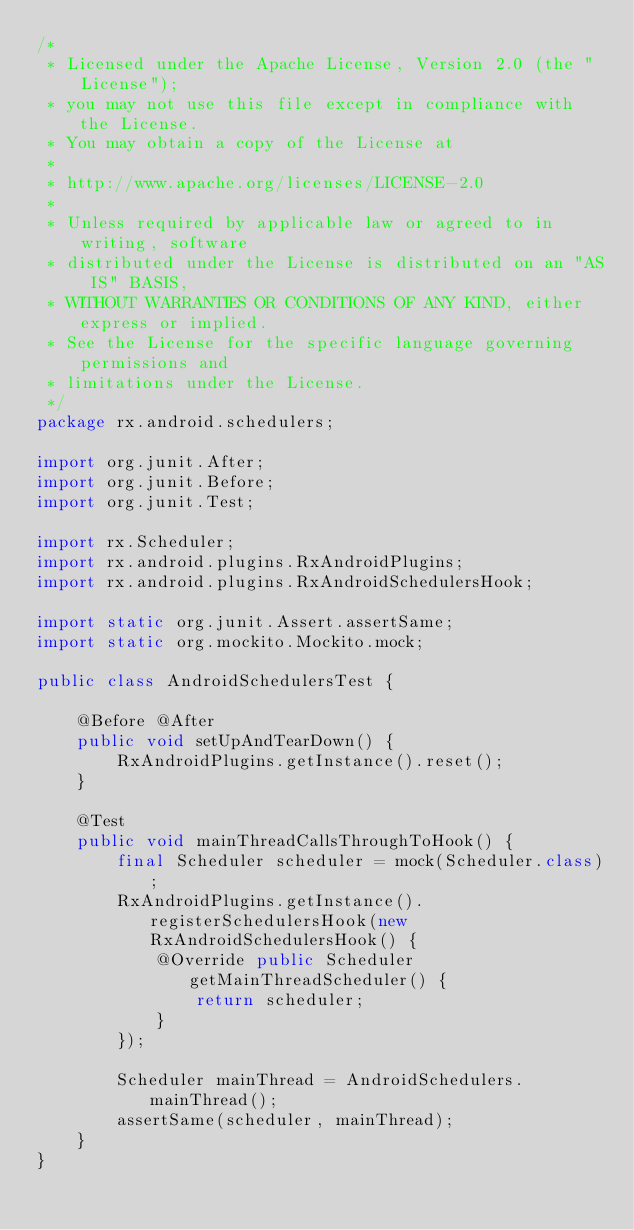Convert code to text. <code><loc_0><loc_0><loc_500><loc_500><_Java_>/*
 * Licensed under the Apache License, Version 2.0 (the "License");
 * you may not use this file except in compliance with the License.
 * You may obtain a copy of the License at
 *
 * http://www.apache.org/licenses/LICENSE-2.0
 *
 * Unless required by applicable law or agreed to in writing, software
 * distributed under the License is distributed on an "AS IS" BASIS,
 * WITHOUT WARRANTIES OR CONDITIONS OF ANY KIND, either express or implied.
 * See the License for the specific language governing permissions and
 * limitations under the License.
 */
package rx.android.schedulers;

import org.junit.After;
import org.junit.Before;
import org.junit.Test;

import rx.Scheduler;
import rx.android.plugins.RxAndroidPlugins;
import rx.android.plugins.RxAndroidSchedulersHook;

import static org.junit.Assert.assertSame;
import static org.mockito.Mockito.mock;

public class AndroidSchedulersTest {

    @Before @After
    public void setUpAndTearDown() {
        RxAndroidPlugins.getInstance().reset();
    }

    @Test
    public void mainThreadCallsThroughToHook() {
        final Scheduler scheduler = mock(Scheduler.class);
        RxAndroidPlugins.getInstance().registerSchedulersHook(new RxAndroidSchedulersHook() {
            @Override public Scheduler getMainThreadScheduler() {
                return scheduler;
            }
        });

        Scheduler mainThread = AndroidSchedulers.mainThread();
        assertSame(scheduler, mainThread);
    }
}
</code> 